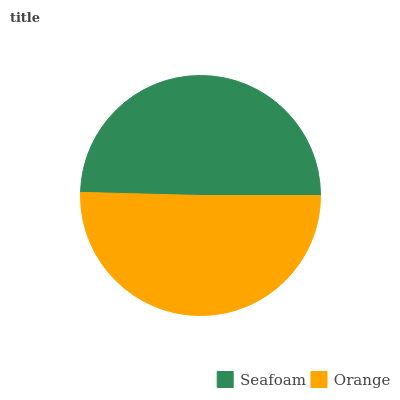Is Seafoam the minimum?
Answer yes or no. Yes. Is Orange the maximum?
Answer yes or no. Yes. Is Orange the minimum?
Answer yes or no. No. Is Orange greater than Seafoam?
Answer yes or no. Yes. Is Seafoam less than Orange?
Answer yes or no. Yes. Is Seafoam greater than Orange?
Answer yes or no. No. Is Orange less than Seafoam?
Answer yes or no. No. Is Orange the high median?
Answer yes or no. Yes. Is Seafoam the low median?
Answer yes or no. Yes. Is Seafoam the high median?
Answer yes or no. No. Is Orange the low median?
Answer yes or no. No. 